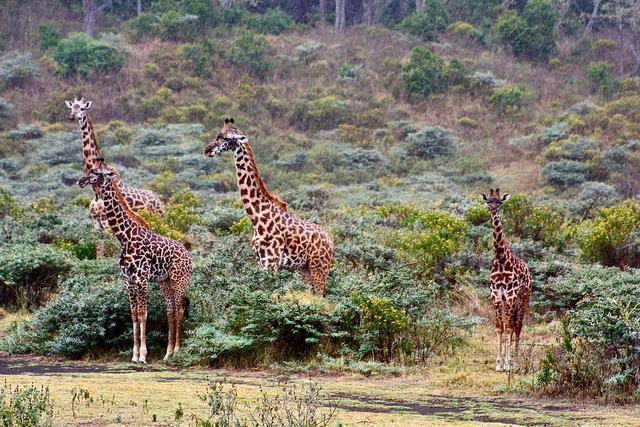How many giraffes?
Give a very brief answer. 4. How many giraffes are there?
Give a very brief answer. 4. How many of the people on the bench are holding umbrellas ?
Give a very brief answer. 0. 